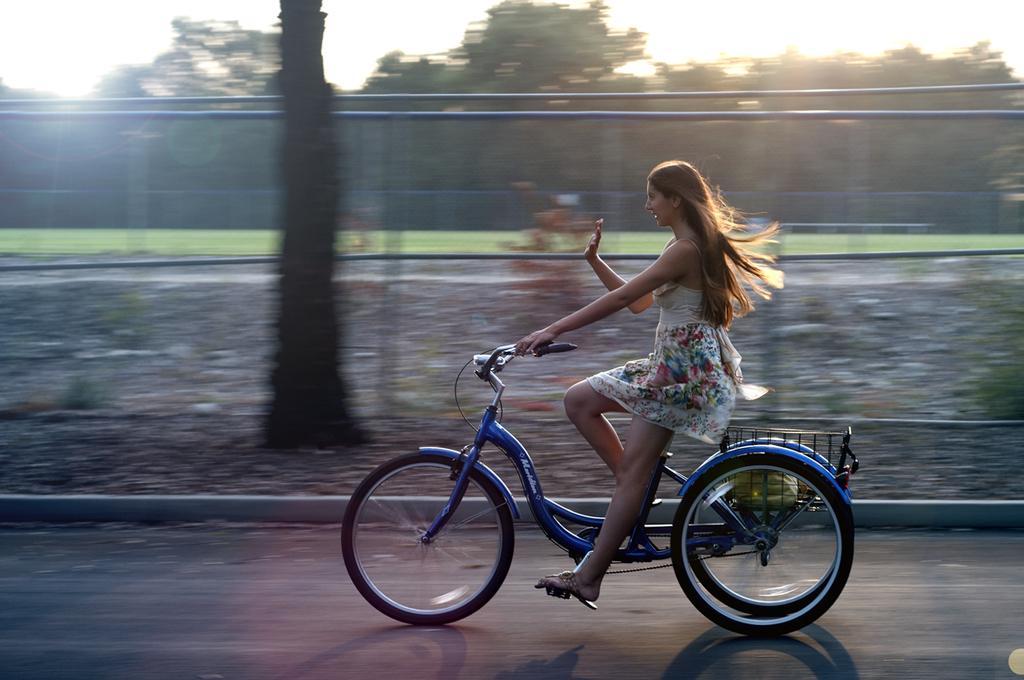How would you summarize this image in a sentence or two? On the background we can see sky, trees. This is a net. We can see a woman riding a bicycle on the road. 